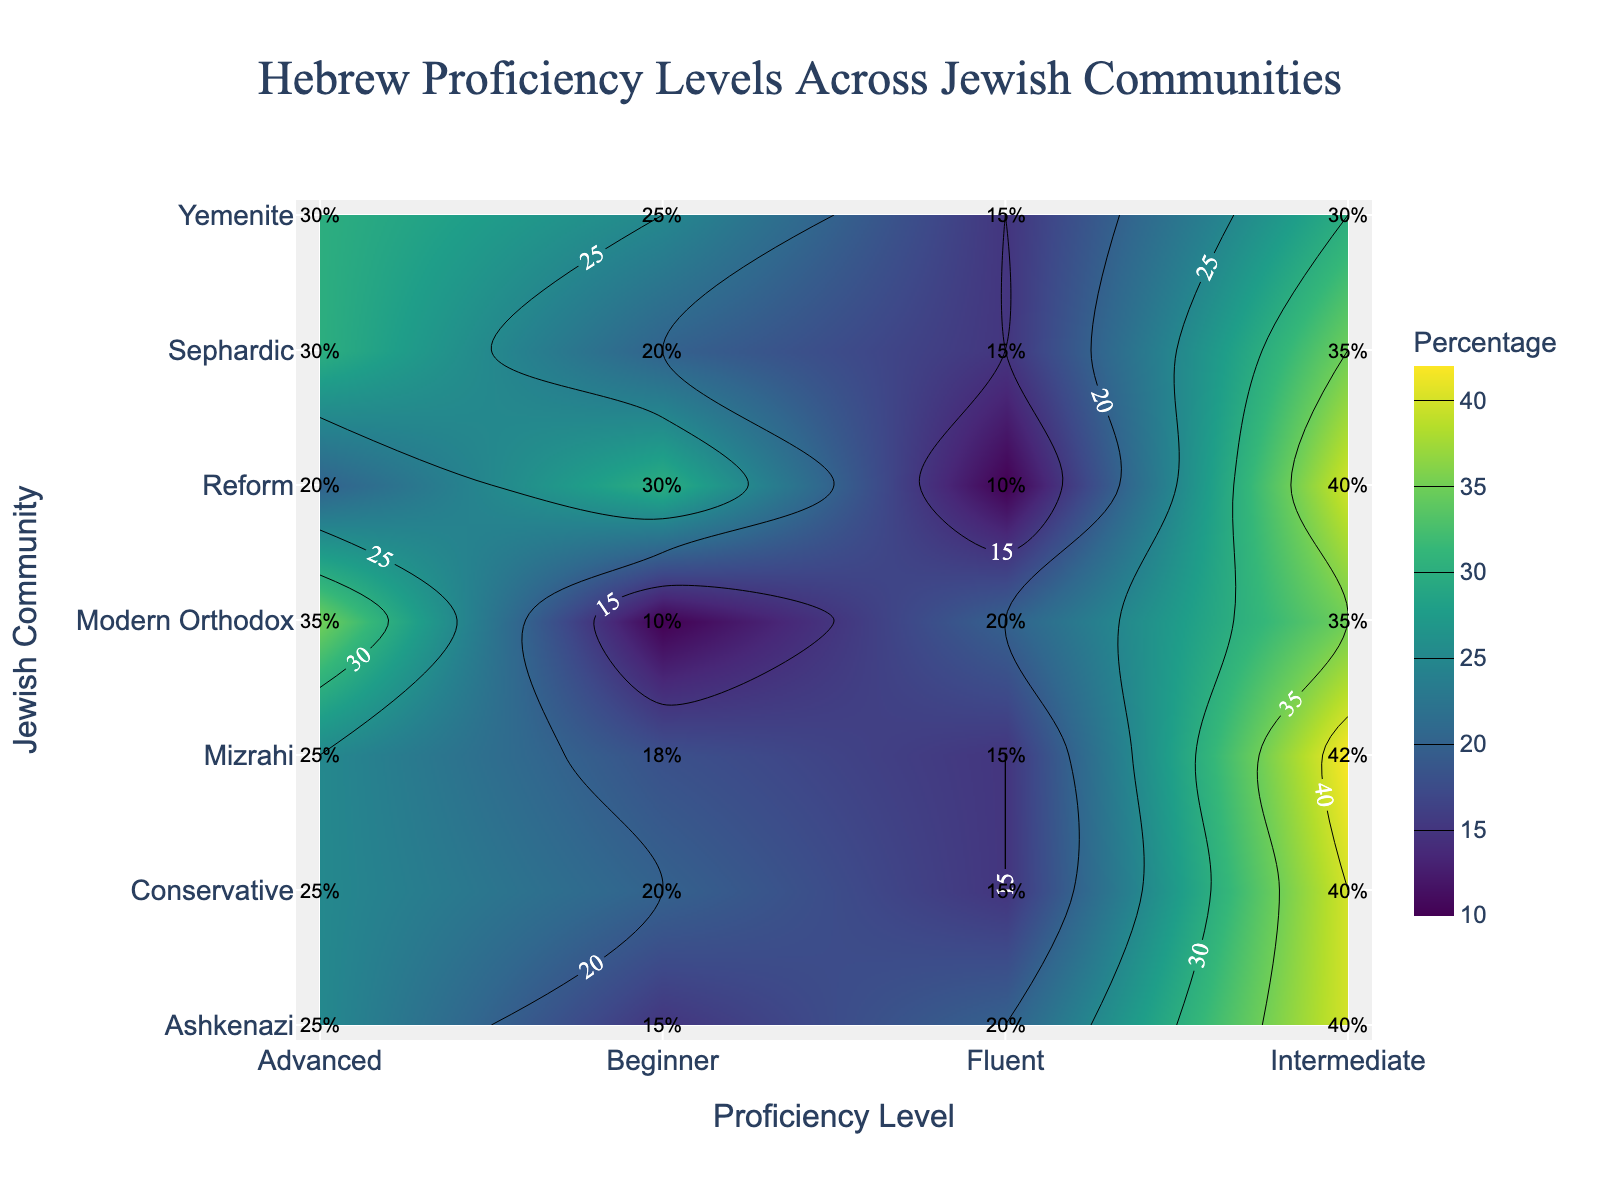Which community shows the highest percentage of beginner proficiency in Hebrew? First, identify the 'Beginner' proficiency level on the x-axis. Then, locate the highest percentage value along the 'Beginner' row. Yemenite has the highest value at 25%.
Answer: Yemenite What is the percentage of intermediate proficiency in the Modern Orthodox community? Locate the Modern Orthodox community on the y-axis and find the corresponding percentage under the 'Intermediate' column. The value is 35%.
Answer: 35% How does the proficiency in Hebrew for the Reform community shift from beginner to fluent? For the Reform community on the y-axis, read across the row from 'Beginner' to 'Fluent'. The percentages decrease from 30% (Beginner) to 40% (Intermediate) to 20% (Advanced) to 10% (Fluent).
Answer: Decreases from 30% to 10% Which community has the lowest percentage of advanced proficiency in Hebrew? Check the 'Advanced' column and find the lowest value across the different communities. The Reform community has the lowest value at 20%.
Answer: Reform How many communities have 15% fluent proficiency in Hebrew? Locate the 'Fluent' column and count the number of communities that have a value of 15%. These are Sephardic, Mizrahi, Yemenite, and Conservative communities, making a total of 4.
Answer: 4 Compare the intermediate proficiency between Ashkenazi and Conservative communities. Locate both Ashkenazi and Conservative on the y-axis and find the corresponding percentages under the 'Intermediate' column. Ashkenazi is at 40% and Conservative is also at 40%.
Answer: Both are 40% Which proficiency level has the highest overall percentage across all communities? Summing up the percentages for each proficiency level across all communities: Beginner (18 + 20 + 18 + 25 + 10 + 20 + 30), Intermediate (42 + 35 + 42 + 30 + 35 + 40 + 40), Advanced (25 + 30 + 25 + 30 + 35 + 25 + 20), Fluent (15 + 15 + 15 + 15 + 20 + 15 + 10). Intermediate totals the highest with 264%.
Answer: Intermediate What is the difference between beginner proficiency percentages in Ashkenazi and Mizrahi communities? Look at the 'Beginner' column for both Ashkenazi (15%) and Mizrahi (18%). The difference is calculated as 18% - 15% = 3%.
Answer: 3% Which community shows a drop in percentage from intermediate to fluent proficiency? Checking each community, Yeminite (30% to 15%), Sephardic (35% to 15%), Mizrahi (42% to 15%), and several others drop in percentage from intermediate to fluent proficiency. Both communities show similar patterns.
Answer: Yemenite, Sephardic, Mizrahi (among others) 